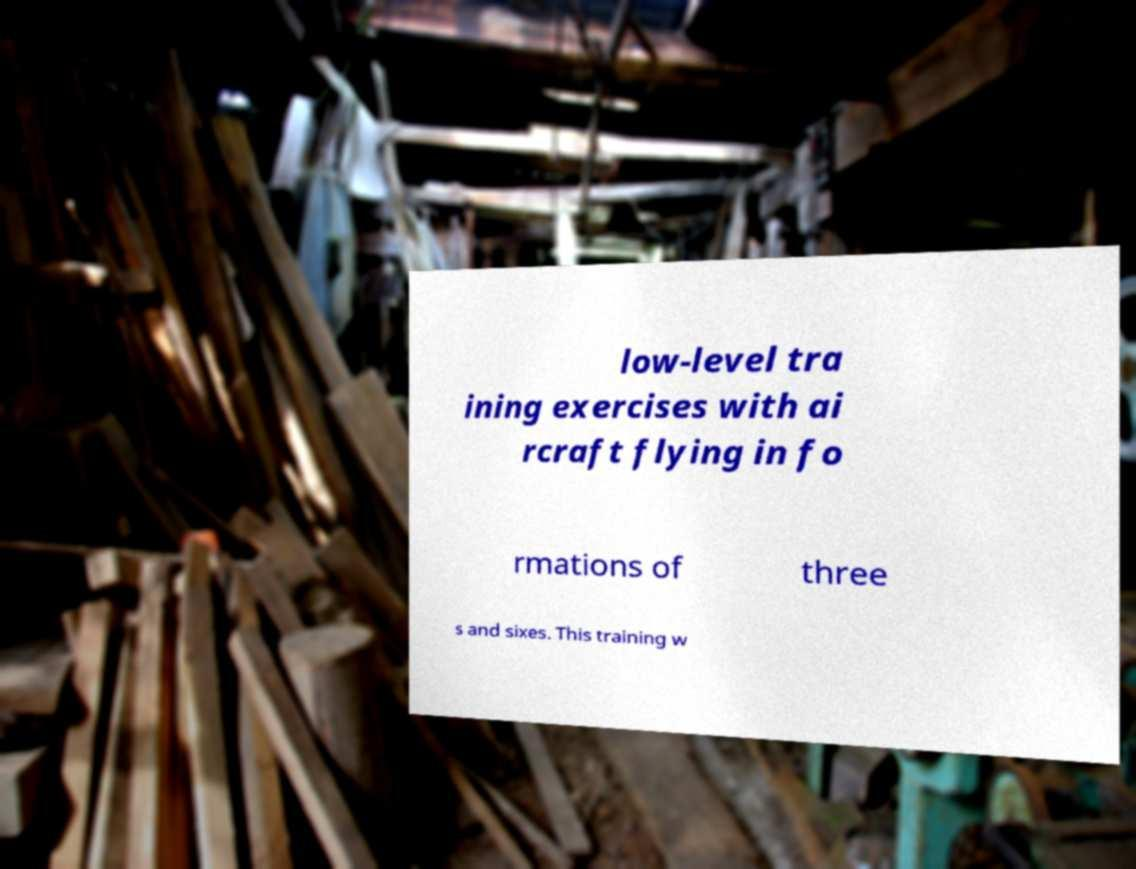Could you assist in decoding the text presented in this image and type it out clearly? low-level tra ining exercises with ai rcraft flying in fo rmations of three s and sixes. This training w 